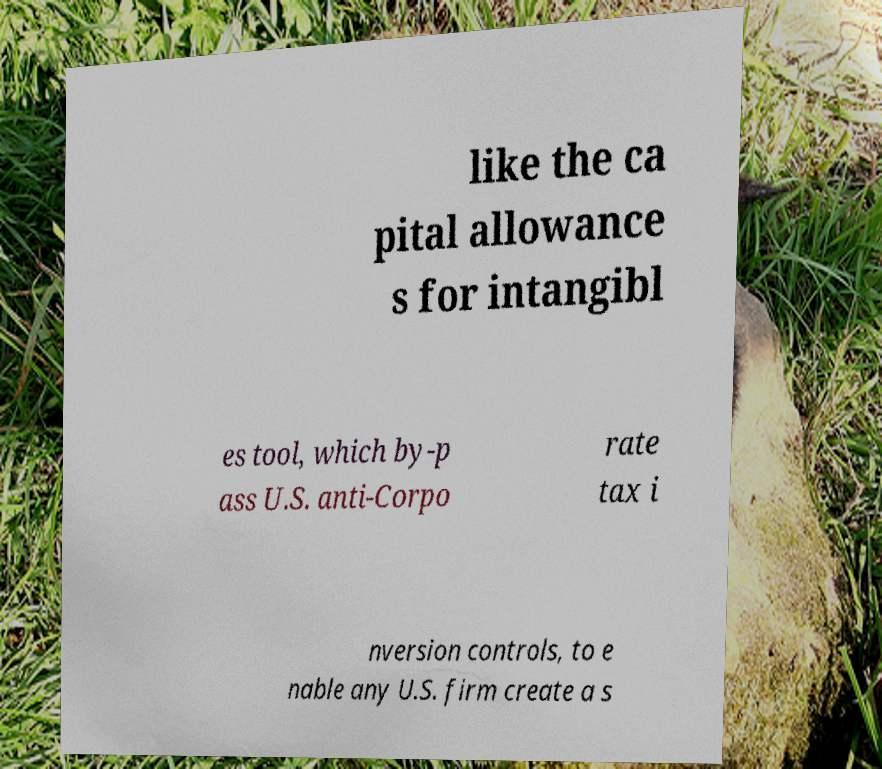For documentation purposes, I need the text within this image transcribed. Could you provide that? like the ca pital allowance s for intangibl es tool, which by-p ass U.S. anti-Corpo rate tax i nversion controls, to e nable any U.S. firm create a s 